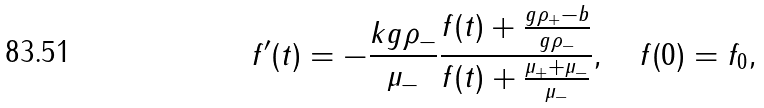Convert formula to latex. <formula><loc_0><loc_0><loc_500><loc_500>f ^ { \prime } ( t ) = - \frac { k g \rho _ { - } } { \mu _ { - } } \frac { f ( t ) + \frac { g \rho _ { + } - b } { g \rho _ { - } } } { f ( t ) + \frac { \mu _ { + } + \mu _ { - } } { \mu _ { - } } } , \quad f ( 0 ) = f _ { 0 } ,</formula> 